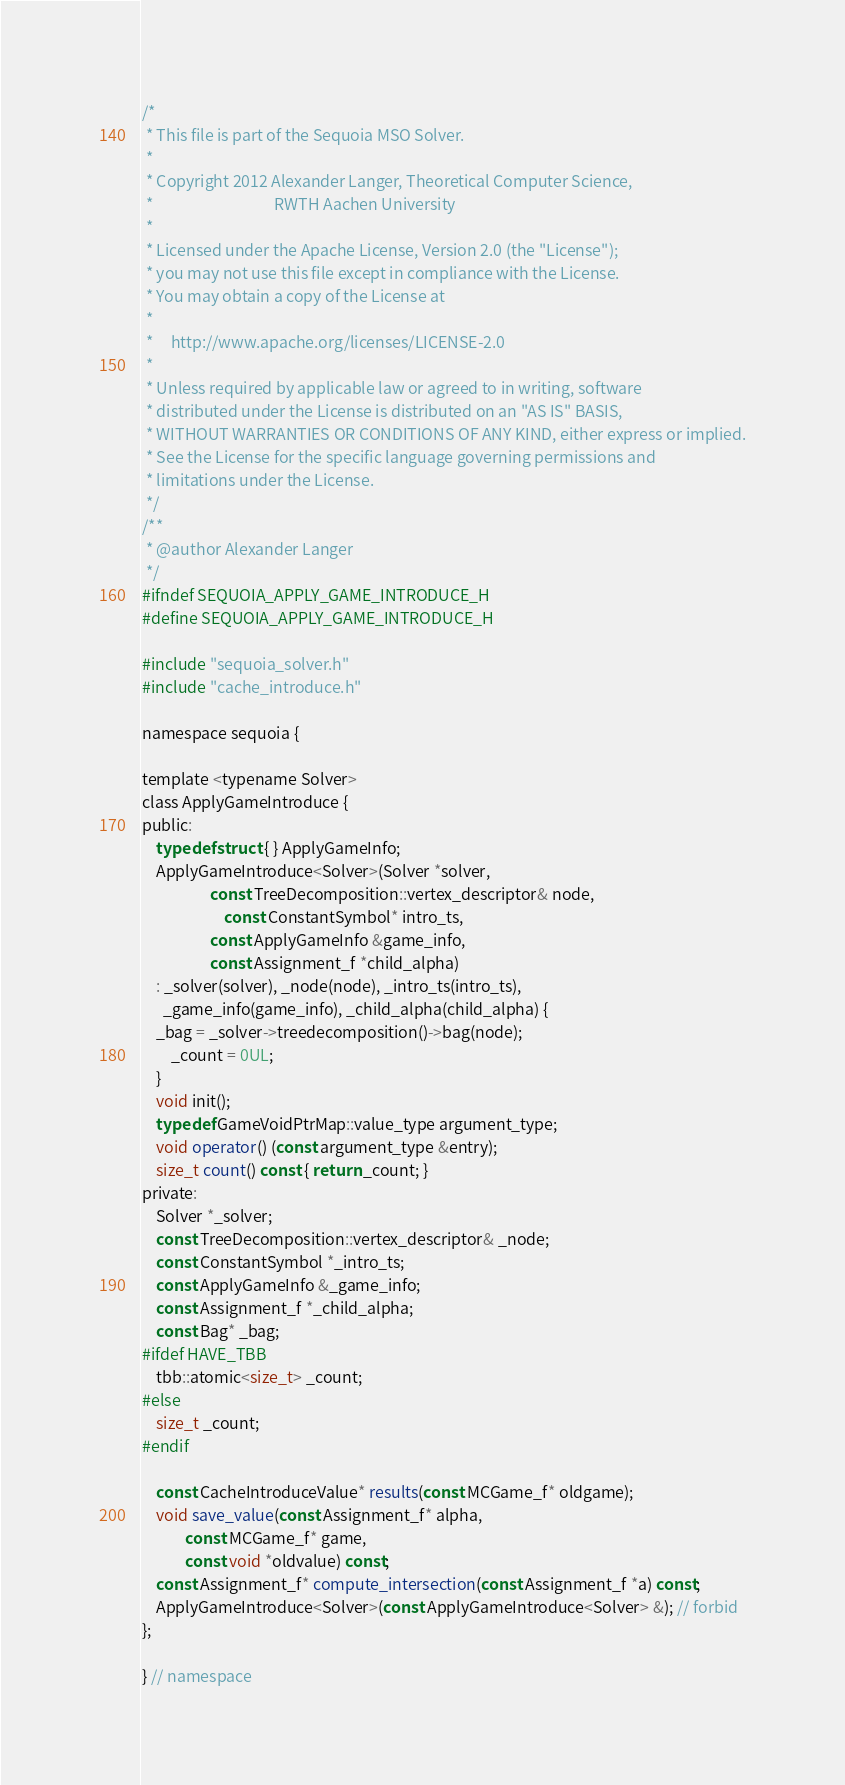Convert code to text. <code><loc_0><loc_0><loc_500><loc_500><_C_>/*
 * This file is part of the Sequoia MSO Solver.
 * 
 * Copyright 2012 Alexander Langer, Theoretical Computer Science,
 *                                  RWTH Aachen University
 *
 * Licensed under the Apache License, Version 2.0 (the "License");
 * you may not use this file except in compliance with the License.
 * You may obtain a copy of the License at
 *
 *     http://www.apache.org/licenses/LICENSE-2.0
 *
 * Unless required by applicable law or agreed to in writing, software
 * distributed under the License is distributed on an "AS IS" BASIS,
 * WITHOUT WARRANTIES OR CONDITIONS OF ANY KIND, either express or implied.
 * See the License for the specific language governing permissions and
 * limitations under the License.
 */
/**
 * @author Alexander Langer
 */
#ifndef SEQUOIA_APPLY_GAME_INTRODUCE_H
#define SEQUOIA_APPLY_GAME_INTRODUCE_H

#include "sequoia_solver.h"
#include "cache_introduce.h"

namespace sequoia {

template <typename Solver>
class ApplyGameIntroduce {
public:
    typedef struct { } ApplyGameInfo;
    ApplyGameIntroduce<Solver>(Solver *solver,
			       const TreeDecomposition::vertex_descriptor& node, 
		               const ConstantSymbol* intro_ts,
			       const ApplyGameInfo &game_info,
			       const Assignment_f *child_alpha)
    : _solver(solver), _node(node), _intro_ts(intro_ts),
      _game_info(game_info), _child_alpha(child_alpha) {
	_bag = _solver->treedecomposition()->bag(node);
        _count = 0UL;
    }
    void init();
    typedef GameVoidPtrMap::value_type argument_type;
    void operator() (const argument_type &entry);
    size_t count() const { return _count; }
private:
    Solver *_solver;
    const TreeDecomposition::vertex_descriptor& _node;
    const ConstantSymbol *_intro_ts;
    const ApplyGameInfo &_game_info;
    const Assignment_f *_child_alpha;
    const Bag* _bag;
#ifdef HAVE_TBB
    tbb::atomic<size_t> _count;
#else
    size_t _count;
#endif

    const CacheIntroduceValue* results(const MCGame_f* oldgame);
    void save_value(const Assignment_f* alpha,
		    const MCGame_f* game,
		    const void *oldvalue) const;
    const Assignment_f* compute_intersection(const Assignment_f *a) const;
    ApplyGameIntroduce<Solver>(const ApplyGameIntroduce<Solver> &); // forbid
};

} // namespace
</code> 